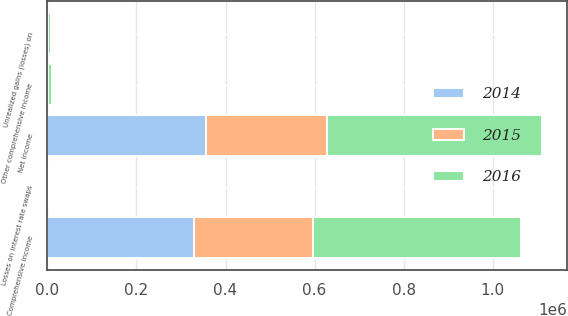Convert chart to OTSL. <chart><loc_0><loc_0><loc_500><loc_500><stacked_bar_chart><ecel><fcel>Net income<fcel>Unrealized gains (losses) on<fcel>Losses on interest rate swaps<fcel>Other comprehensive income<fcel>Comprehensive income<nl><fcel>2016<fcel>483273<fcel>5855<fcel>1586<fcel>7662<fcel>465419<nl><fcel>2015<fcel>271983<fcel>214<fcel>1678<fcel>593<fcel>267644<nl><fcel>2014<fcel>356111<fcel>1192<fcel>1685<fcel>1813<fcel>329565<nl></chart> 